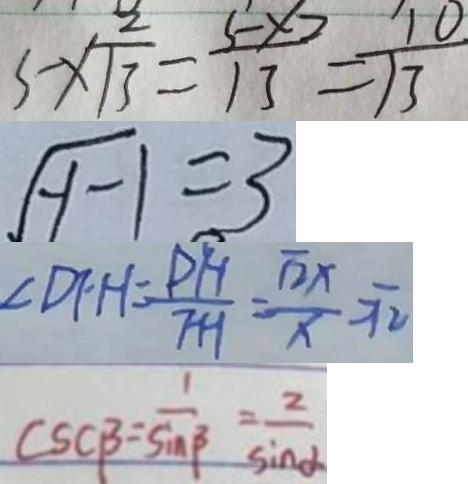<formula> <loc_0><loc_0><loc_500><loc_500>5 \times \frac { 2 } { 1 3 } = \frac { 5 \times 2 } { 1 3 } = \frac { 1 0 } { 1 3 } 
 \sqrt { y - 1 } = 3 
 \angle D F H = \frac { P H } { F H } = \frac { \sqrt { 2 } x } { x } = \sqrt { 2 } 
 s c \beta = \frac { 1 } { \sin \beta } = \frac { 2 } { \sin \alpha }</formula> 